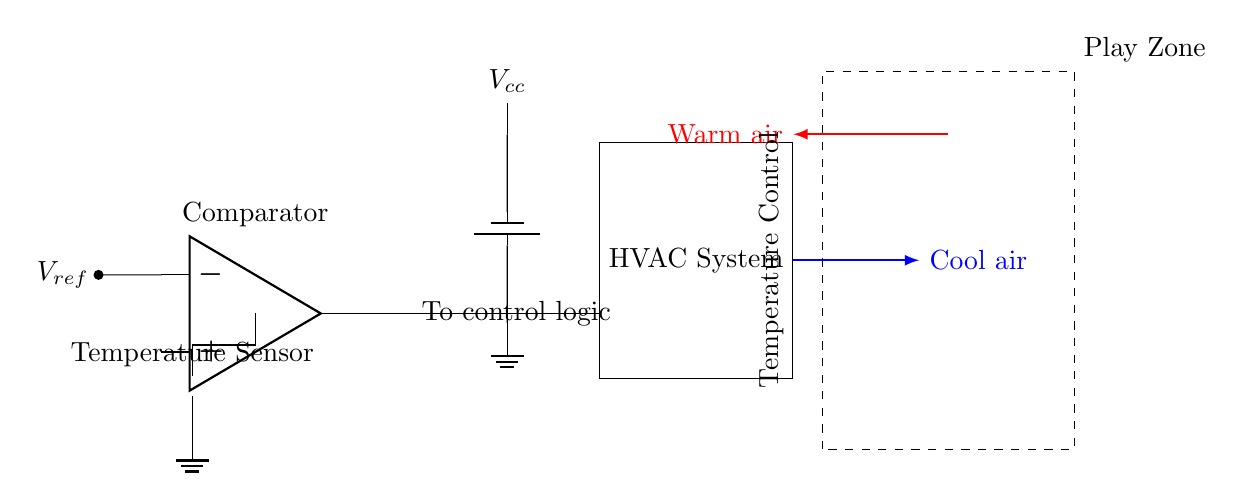What component is used to sense temperature? The component used to sense temperature in the circuit is the thermistor, which is depicted at the leftmost position in the diagram.
Answer: Thermistor What does the output of the comparator control? The output of the comparator, indicated as "To control logic," is responsible for controlling the HVAC system based on the temperature readings from the thermistor.
Answer: HVAC system What is the supply voltage for the circuit? The supply voltage, represented as \( V_{cc} \), is shown connected to the power supply and provides necessary power to the circuit. The value is not specified but is indicated in the diagram.
Answer: \( V_{cc} \) How does cool air move from the HVAC? The airflow direction from the HVAC is indicated by the blue arrow, showing that cool air is expelled to the right. This is a significant connection as it represents the output of the HVAC system's cooling function.
Answer: Cool air What role does the reference voltage play in the circuit? The reference voltage, noted as \( V_{ref} \), is used as a comparison point by the comparator within the circuit to determine whether the temperature from the thermistor is above or below the desired level. This helps regulate the HVAC's response.
Answer: Comparator input What indicates the HVAC system's purpose in the circuit? The HVAC system is contained within a rectangle labeled as "HVAC System," highlighting its function in maintaining temperature control based on inputs from the comparator. The label clearly defines its role in the circuitry.
Answer: Temperature Control 